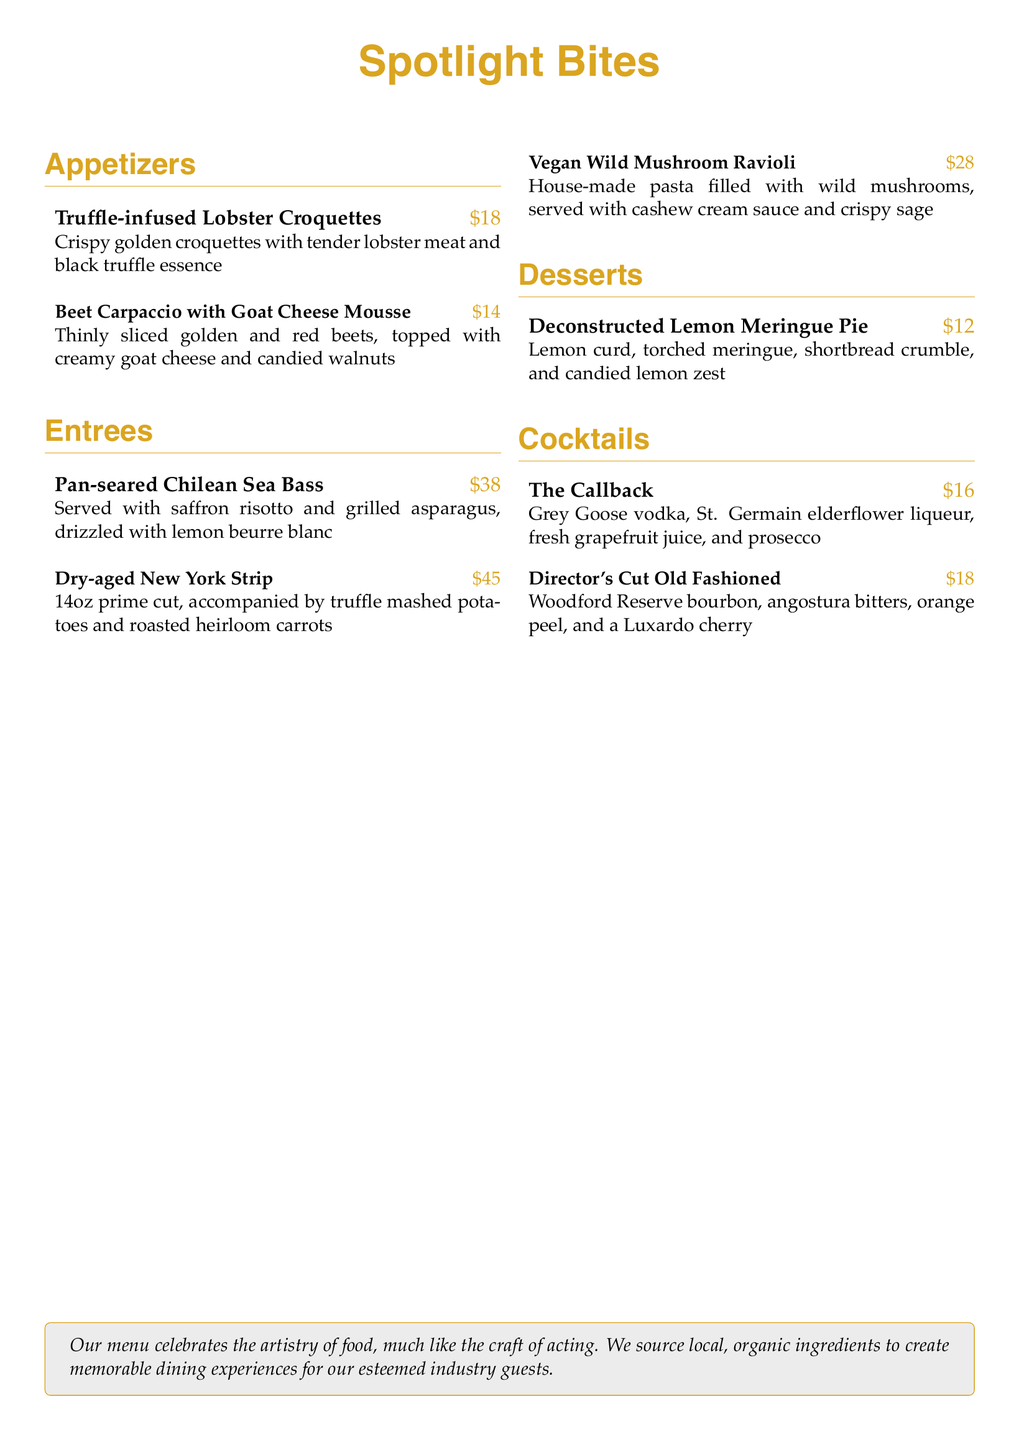What is the price of Truffle-infused Lobster Croquettes? The price of Truffle-infused Lobster Croquettes is listed on the menu, which is $18.
Answer: $18 What is the main ingredient in the Vegan Wild Mushroom Ravioli? The main ingredient in the Vegan Wild Mushroom Ravioli is filled with wild mushrooms, as specified in the description.
Answer: Wild mushrooms How many ounces is the Dry-aged New York Strip? The menu notes that the Dry-aged New York Strip is a 14oz prime cut.
Answer: 14oz What type of cheese is used in the Beet Carpaccio? The document specifies that the Beet Carpaccio is topped with creamy goat cheese, indicating the type of cheese used.
Answer: Goat cheese Which cocktail includes Grey Goose vodka? The cocktail that includes Grey Goose vodka is The Callback, as mentioned in the cocktails section.
Answer: The Callback What dish is served with saffron risotto? The dish served with saffron risotto is the Pan-seared Chilean Sea Bass, according to the menu.
Answer: Pan-seared Chilean Sea Bass What dessert features lemon curd? The dessert that features lemon curd is the Deconstructed Lemon Meringue Pie, as stated in the desserts section.
Answer: Deconstructed Lemon Meringue Pie How many appetizers are listed in the menu? The menu lists a total of two appetizers, specifically Truffle-infused Lobster Croquettes and Beet Carpaccio.
Answer: 2 What is a unique selling point mentioned about the menu's ingredients? The menu highlights that local, organic ingredients are sourced to create the dishes, emphasizing a focus on quality.
Answer: Local, organic ingredients 